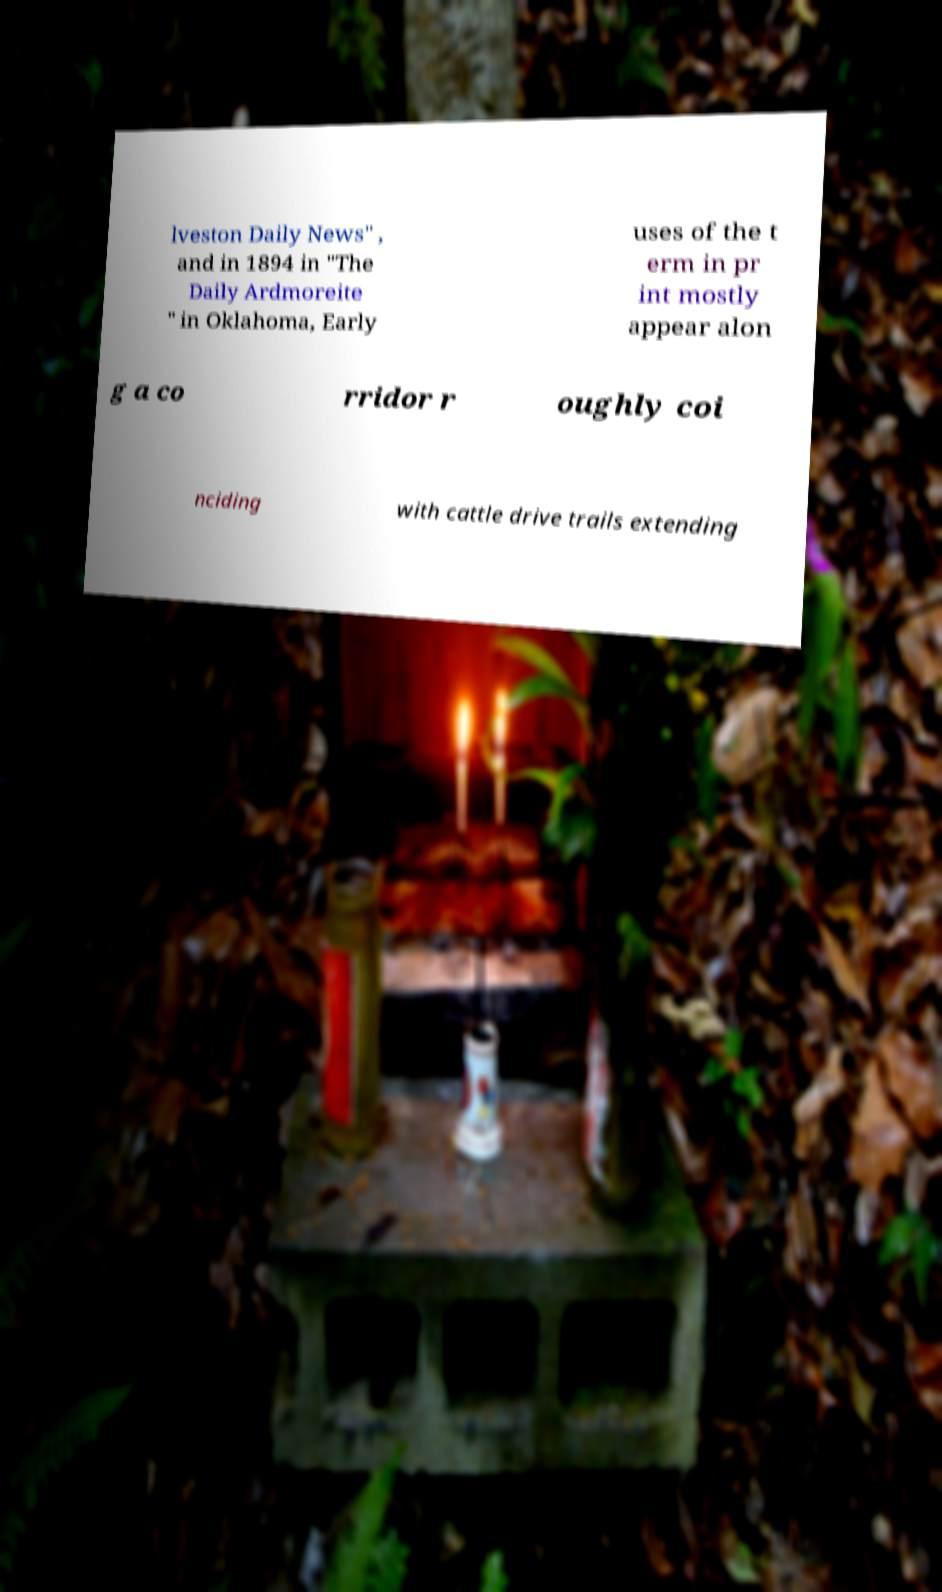Could you assist in decoding the text presented in this image and type it out clearly? lveston Daily News" , and in 1894 in "The Daily Ardmoreite " in Oklahoma, Early uses of the t erm in pr int mostly appear alon g a co rridor r oughly coi nciding with cattle drive trails extending 